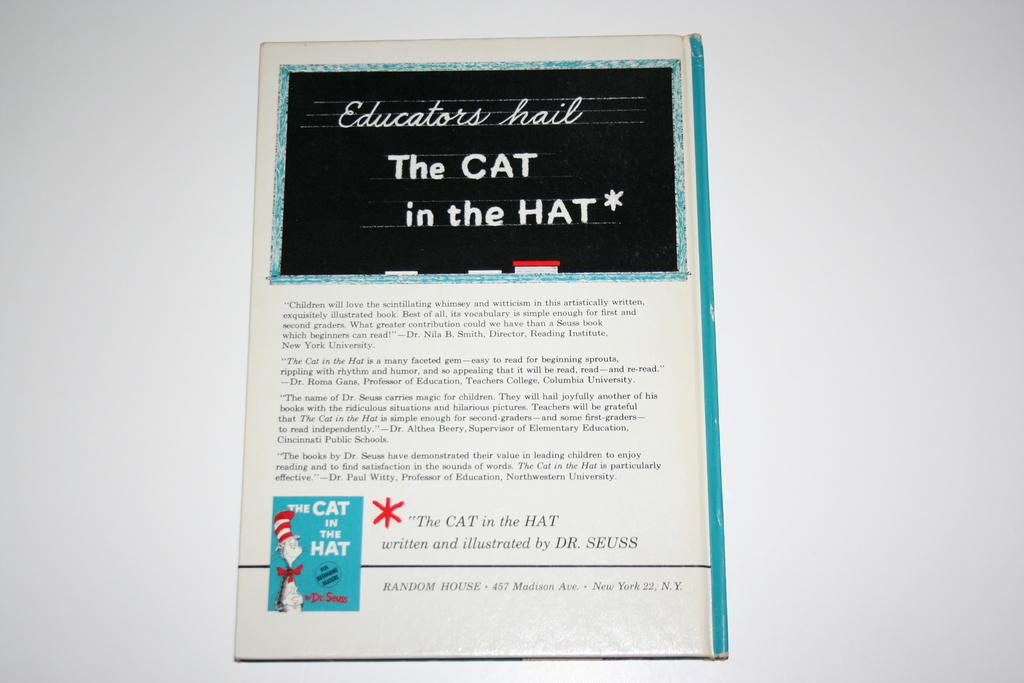What is the main subject of the image? There is an object in the image. Can you describe the appearance of the object? The object has a cartoon photo on it. Is there any text on the object? Yes, there is writing on the object. What is the color of the surface the object is placed on? The object is on a white color surface. Are there any animals from the zoo visible in the image? There is no mention of animals or a zoo in the provided facts, so we cannot determine if any animals are visible in the image. 